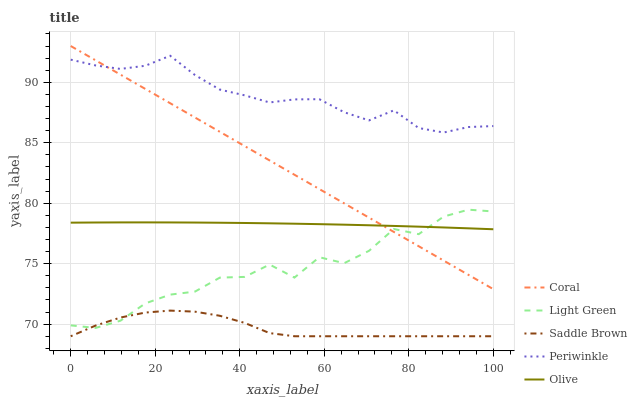Does Saddle Brown have the minimum area under the curve?
Answer yes or no. Yes. Does Periwinkle have the maximum area under the curve?
Answer yes or no. Yes. Does Coral have the minimum area under the curve?
Answer yes or no. No. Does Coral have the maximum area under the curve?
Answer yes or no. No. Is Coral the smoothest?
Answer yes or no. Yes. Is Light Green the roughest?
Answer yes or no. Yes. Is Periwinkle the smoothest?
Answer yes or no. No. Is Periwinkle the roughest?
Answer yes or no. No. Does Saddle Brown have the lowest value?
Answer yes or no. Yes. Does Coral have the lowest value?
Answer yes or no. No. Does Coral have the highest value?
Answer yes or no. Yes. Does Periwinkle have the highest value?
Answer yes or no. No. Is Saddle Brown less than Coral?
Answer yes or no. Yes. Is Olive greater than Saddle Brown?
Answer yes or no. Yes. Does Coral intersect Periwinkle?
Answer yes or no. Yes. Is Coral less than Periwinkle?
Answer yes or no. No. Is Coral greater than Periwinkle?
Answer yes or no. No. Does Saddle Brown intersect Coral?
Answer yes or no. No. 